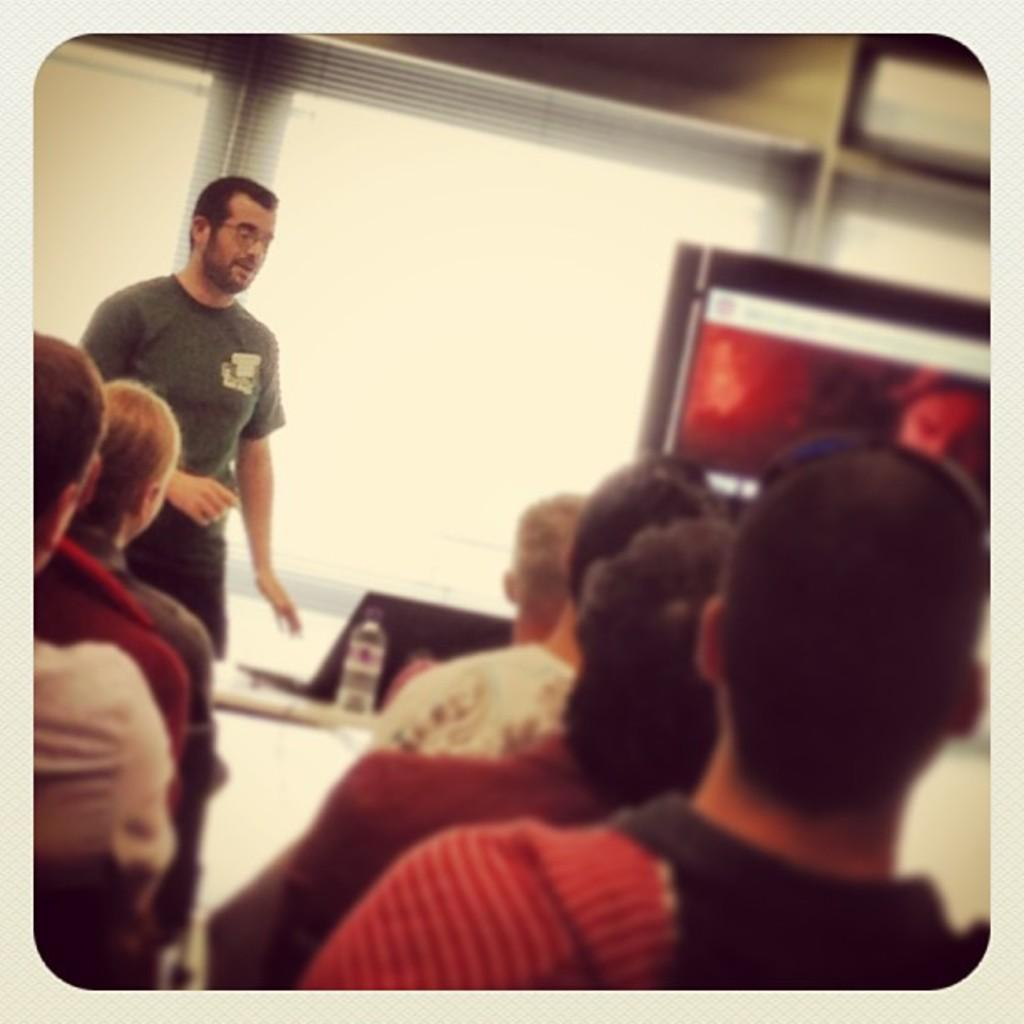What are the people in the image doing? The people in the image are sitting. Is there anyone standing in the image? Yes, there is a person standing in the image. What can be seen on the table in the image? There is a water bottle and laptops on the table in the image. What is visible through the window in the image? The facts do not specify what can be seen through the window, so we cannot answer that question definitively. What type of liquid is being poured into the laptops in the image? There is no liquid being poured into the laptops in the image; they are not depicted as being damaged or destroyed. What is the middle of the image showing? The facts do not specify a "middle" of the image, so we cannot answer that question definitively. 